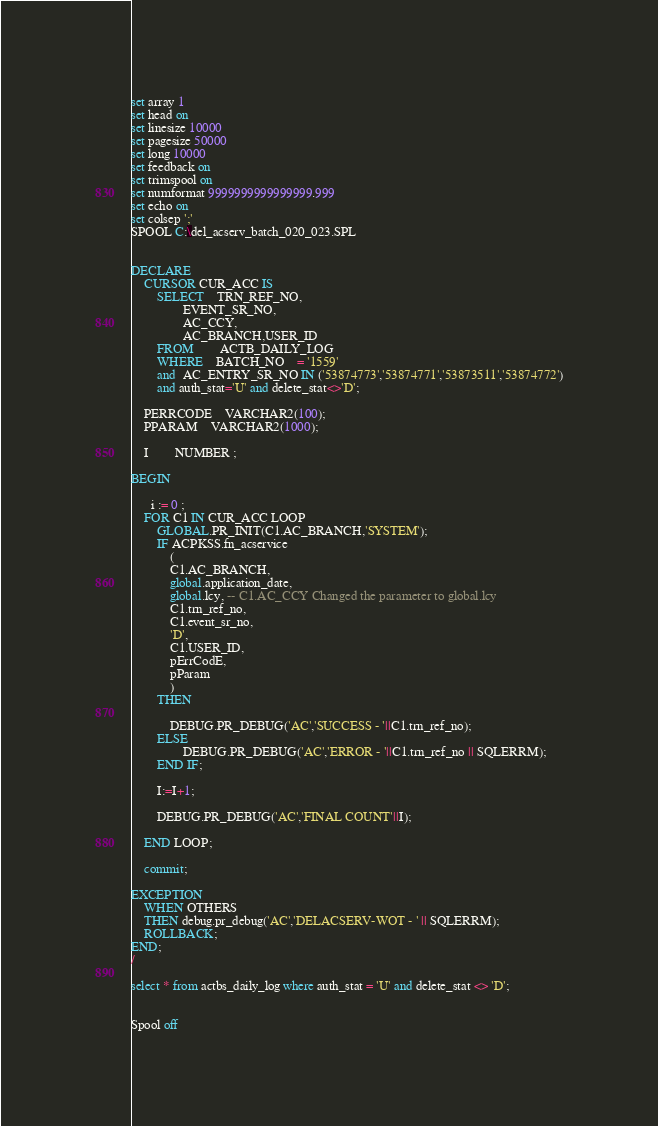Convert code to text. <code><loc_0><loc_0><loc_500><loc_500><_SQL_>set array 1
set head on
set linesize 10000
set pagesize 50000
set long 10000
set feedback on
set trimspool on
set numformat 9999999999999999.999
set echo on
set colsep ';'
SPOOL C:\del_acserv_batch_020_023.SPL


DECLARE
	CURSOR CUR_ACC IS
		SELECT 	TRN_REF_NO,
				EVENT_SR_NO,
				AC_CCY,	
				AC_BRANCH,USER_ID
		FROM 		ACTB_DAILY_LOG
		WHERE 	BATCH_NO	= '1559'
		and  AC_ENTRY_SR_NO IN ('53874773','53874771','53873511','53874772')
		and auth_stat='U' and delete_stat<>'D';
		
	PERRCODE 	VARCHAR2(100);
	PPARAM 	VARCHAR2(1000);

	I 		NUMBER ;

BEGIN
	
      i := 0 ;
	FOR C1 IN CUR_ACC LOOP
		GLOBAL.PR_INIT(C1.AC_BRANCH,'SYSTEM');
		IF ACPKSS.fn_acservice
   			(
			C1.AC_BRANCH,
			global.application_date,
			global.lcy, -- C1.AC_CCY Changed the parameter to global.lcy
			C1.trn_ref_no,
			C1.event_sr_no,
			'D',
			C1.USER_ID,
			pErrCodE,
			pParam	
		   	) 
		THEN
		   	
			DEBUG.PR_DEBUG('AC','SUCCESS - '||C1.trn_ref_no);
		ELSE
		    	DEBUG.PR_DEBUG('AC','ERROR - '||C1.trn_ref_no || SQLERRM);
		END IF;

		I:=I+1;

		DEBUG.PR_DEBUG('AC','FINAL COUNT'||I);

	END LOOP;

	commit;

EXCEPTION
	WHEN OTHERS
	THEN debug.pr_debug('AC','DELACSERV-WOT - ' || SQLERRM);
	ROLLBACK;
END;
/

select * from actbs_daily_log where auth_stat = 'U' and delete_stat <> 'D';


Spool off</code> 